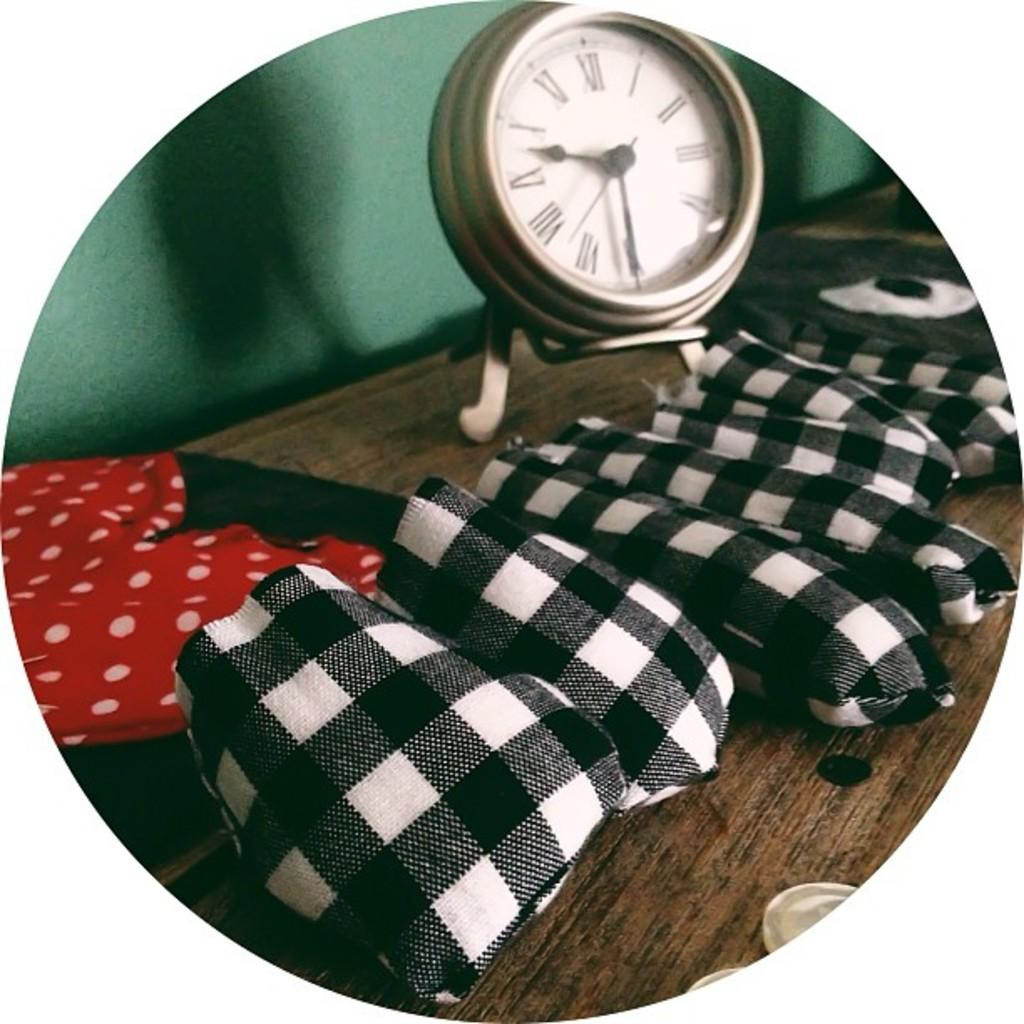Provide a one-sentence caption for the provided image. A white faces clock with black arms reads "9:31.". 